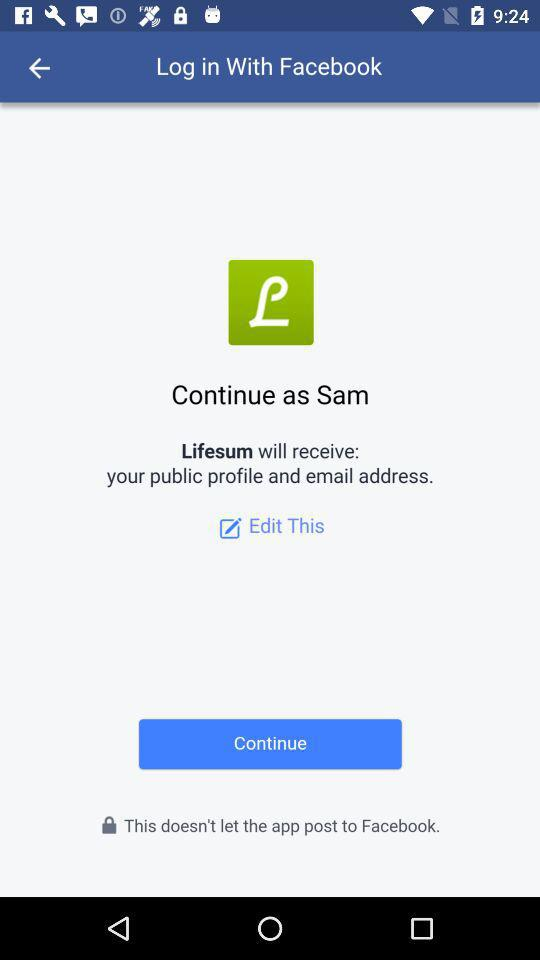What application is asking for permission? The application is "Lifesum". 